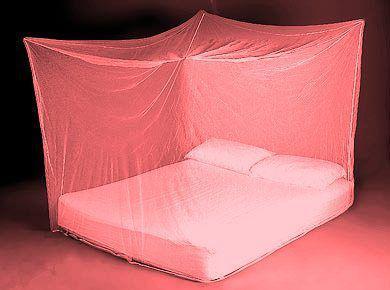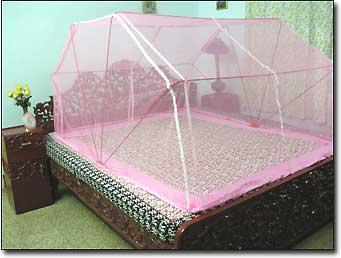The first image is the image on the left, the second image is the image on the right. Assess this claim about the two images: "Each image shows a bed with a rounded dome-shaped canopy with non-dark trim over its mattress, and one bed is positioned at a leftward angle.". Correct or not? Answer yes or no. No. The first image is the image on the left, the second image is the image on the right. Given the left and right images, does the statement "In each image, an igloo-shaped net cover is positioned over a double bed with brown and white pillows." hold true? Answer yes or no. No. 